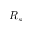Convert formula to latex. <formula><loc_0><loc_0><loc_500><loc_500>R _ { s }</formula> 